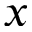Convert formula to latex. <formula><loc_0><loc_0><loc_500><loc_500>x</formula> 